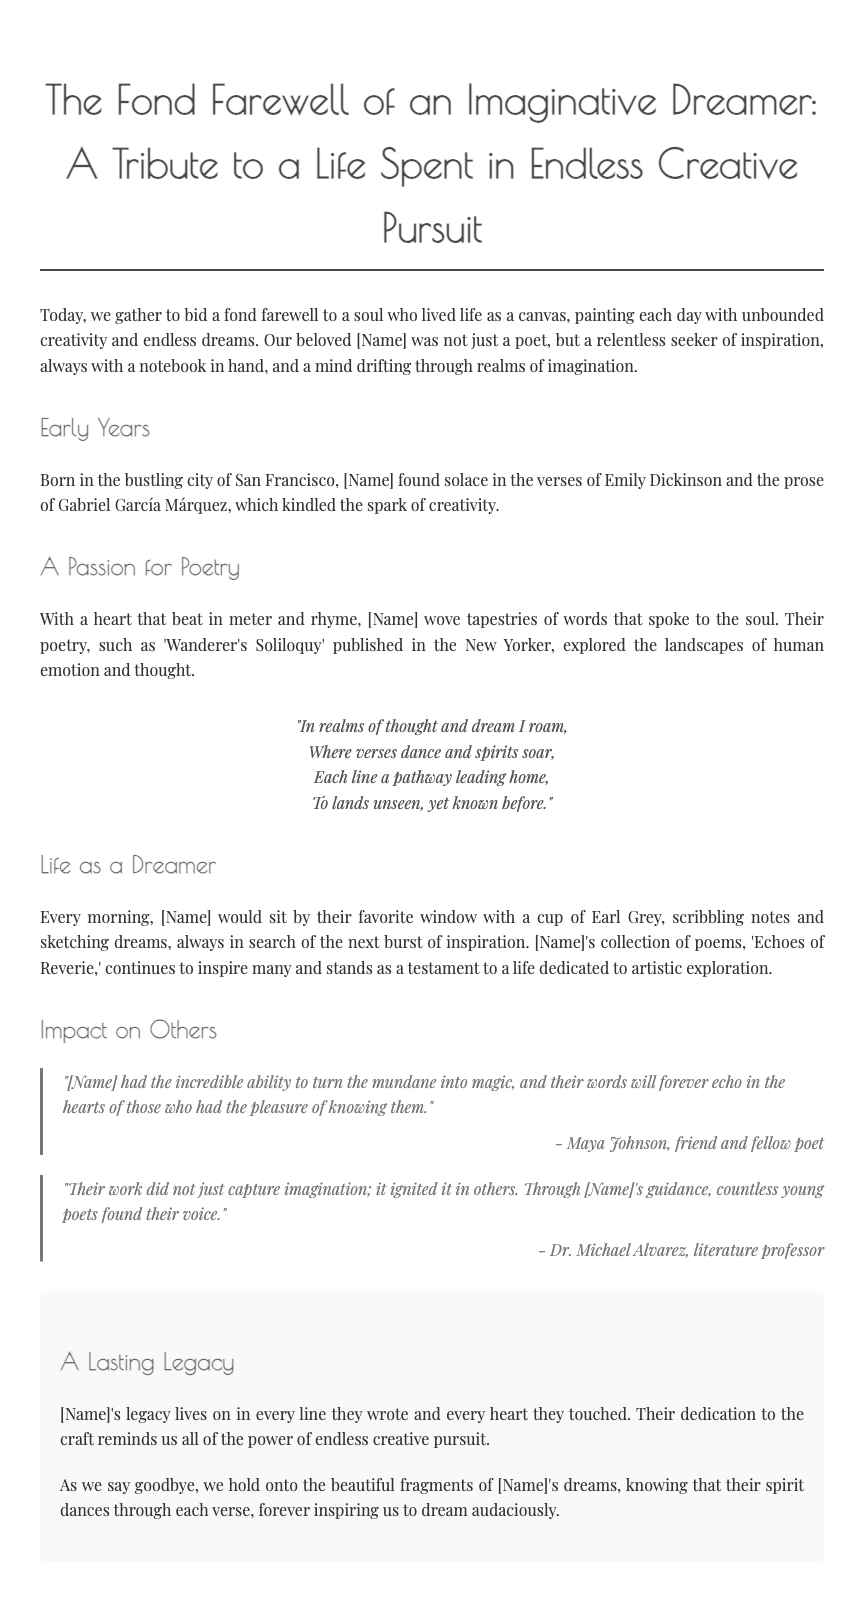What is the title of the eulogy? The title is presented at the top of the document and emphasizes the imaginative nature of the individual being honored.
Answer: The Fond Farewell of an Imaginative Dreamer: A Tribute to a Life Spent in Endless Creative Pursuit Where was [Name] born? The document states the birthplace within the context of their early years, reflecting their background.
Answer: San Francisco What is the name of [Name]'s published poem mentioned? The eulogy highlights one specific work during the section on poetry to showcase their creative contributions.
Answer: Wanderer's Soliloquy Who quoted about [Name]'s ability to turn the mundane into magic? The quotes provide emotional reflections from friends and colleagues, identifying their influence on others.
Answer: Maya Johnson What was [Name]'s collection of poems called? The legacy they left behind is referenced through this collection, which continues to inspire.
Answer: Echoes of Reverie How did [Name] like to start their mornings? This detail gives insight into their daily routine and passion for creativity, emphasizing their dedication.
Answer: With a cup of Earl Grey What term describes [Name]'s impact according to Dr. Michael Alvarez? The document conveys how [Name] affected others' creativity and growth, suggesting their broader influence.
Answer: Ignite What does [Name]'s legacy remind us of? The final sections encapsulate what their life represented, encouraging others to embrace creativity.
Answer: The power of endless creative pursuit 